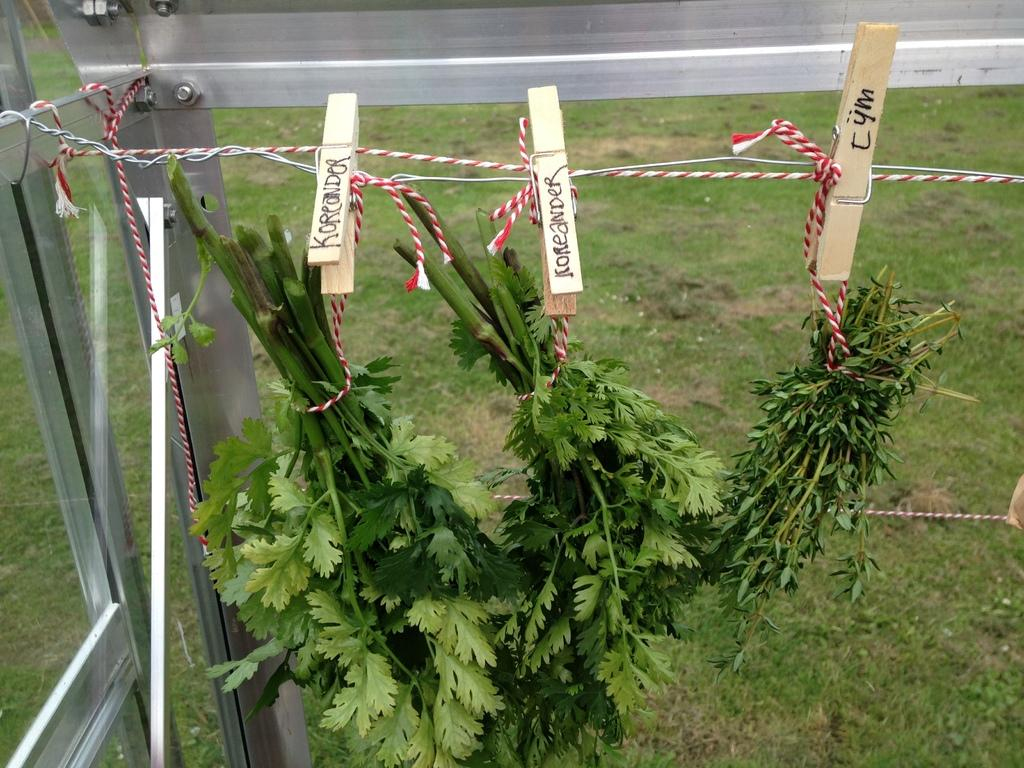<image>
Create a compact narrative representing the image presented. Bunches of Koreander are hanging by a clothespin. 